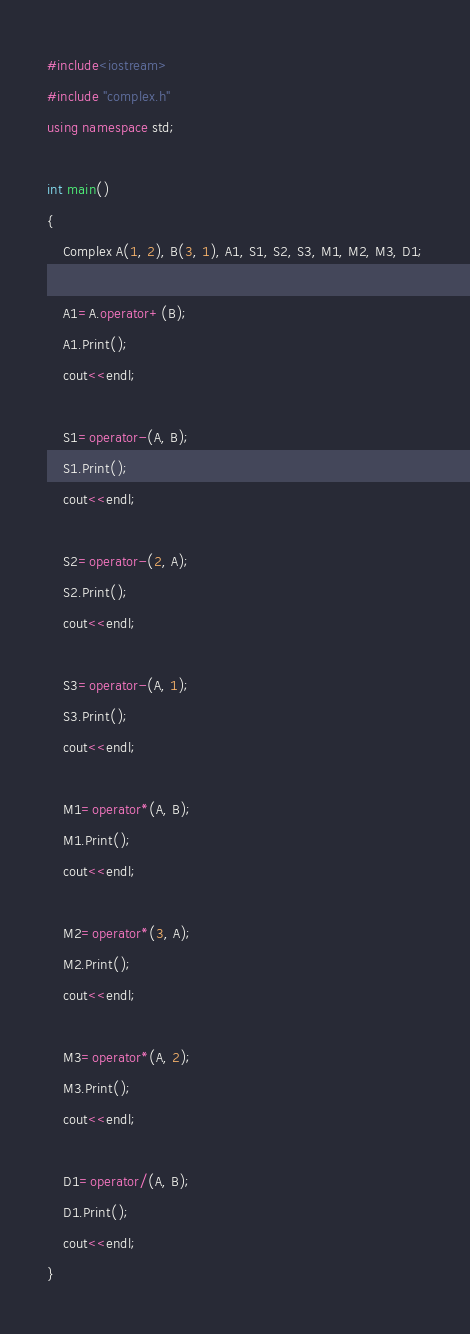Convert code to text. <code><loc_0><loc_0><loc_500><loc_500><_C++_>#include<iostream>
#include "complex.h"
using namespace std;

int main()
{
    Complex A(1, 2), B(3, 1), A1, S1, S2, S3, M1, M2, M3, D1;

    A1=A.operator+(B);
    A1.Print();
    cout<<endl;

    S1=operator-(A, B);
    S1.Print();
    cout<<endl;

    S2=operator-(2, A);
    S2.Print();
    cout<<endl;

    S3=operator-(A, 1);
    S3.Print();
    cout<<endl;

    M1=operator*(A, B);
    M1.Print();
    cout<<endl;

    M2=operator*(3, A);
    M2.Print();
    cout<<endl;

    M3=operator*(A, 2);
    M3.Print();
    cout<<endl;

    D1=operator/(A, B);
    D1.Print();
    cout<<endl;
}
</code> 